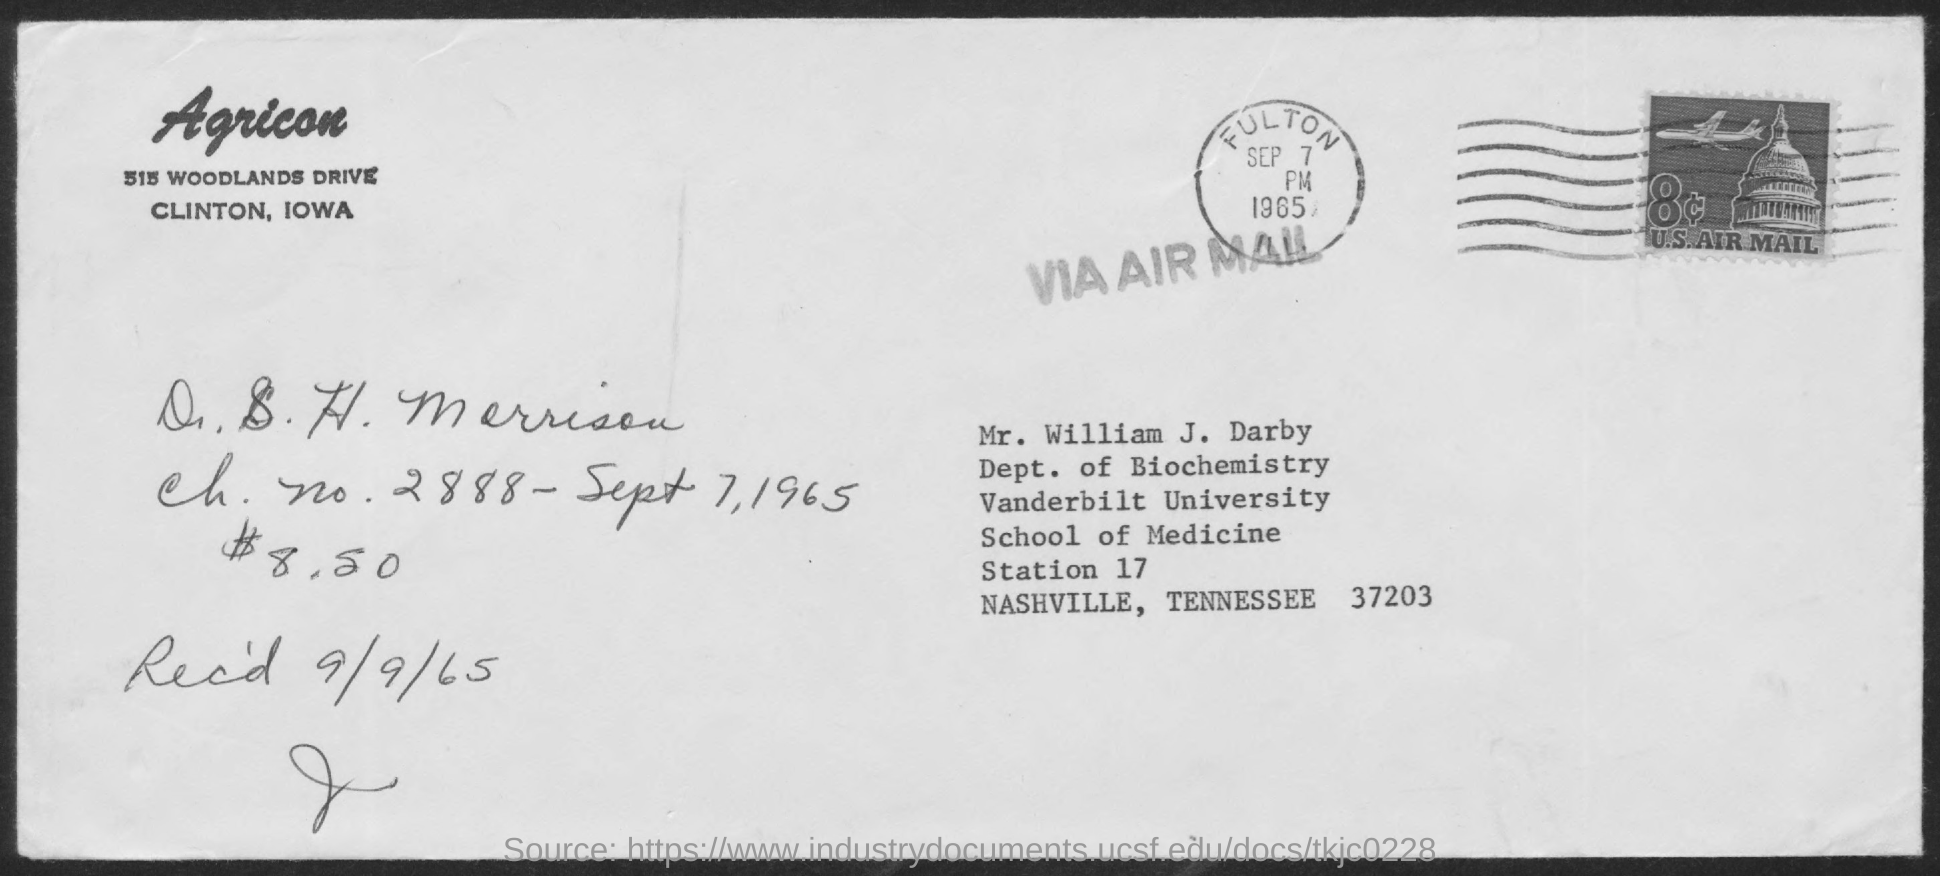Specify some key components in this picture. The letter is addressed to Mr. William J. Darby. 